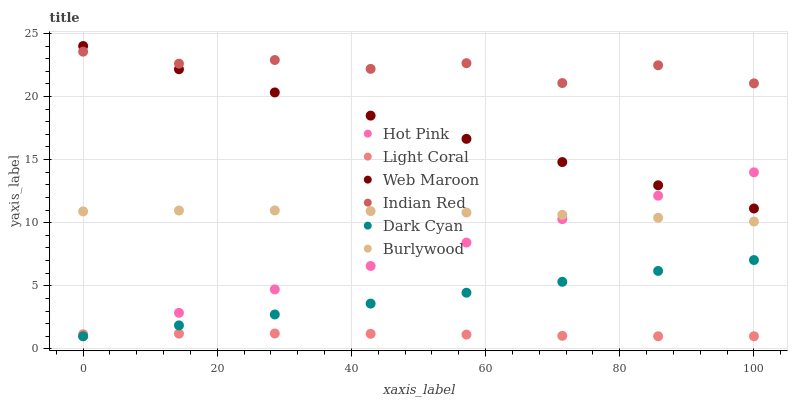Does Light Coral have the minimum area under the curve?
Answer yes or no. Yes. Does Indian Red have the maximum area under the curve?
Answer yes or no. Yes. Does Hot Pink have the minimum area under the curve?
Answer yes or no. No. Does Hot Pink have the maximum area under the curve?
Answer yes or no. No. Is Web Maroon the smoothest?
Answer yes or no. Yes. Is Indian Red the roughest?
Answer yes or no. Yes. Is Hot Pink the smoothest?
Answer yes or no. No. Is Hot Pink the roughest?
Answer yes or no. No. Does Hot Pink have the lowest value?
Answer yes or no. Yes. Does Web Maroon have the lowest value?
Answer yes or no. No. Does Web Maroon have the highest value?
Answer yes or no. Yes. Does Hot Pink have the highest value?
Answer yes or no. No. Is Dark Cyan less than Web Maroon?
Answer yes or no. Yes. Is Indian Red greater than Burlywood?
Answer yes or no. Yes. Does Hot Pink intersect Light Coral?
Answer yes or no. Yes. Is Hot Pink less than Light Coral?
Answer yes or no. No. Is Hot Pink greater than Light Coral?
Answer yes or no. No. Does Dark Cyan intersect Web Maroon?
Answer yes or no. No. 